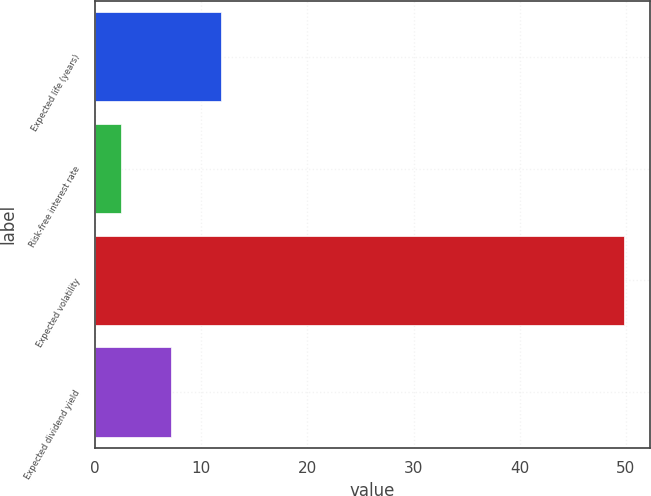Convert chart to OTSL. <chart><loc_0><loc_0><loc_500><loc_500><bar_chart><fcel>Expected life (years)<fcel>Risk-free interest rate<fcel>Expected volatility<fcel>Expected dividend yield<nl><fcel>11.88<fcel>2.4<fcel>49.8<fcel>7.14<nl></chart> 